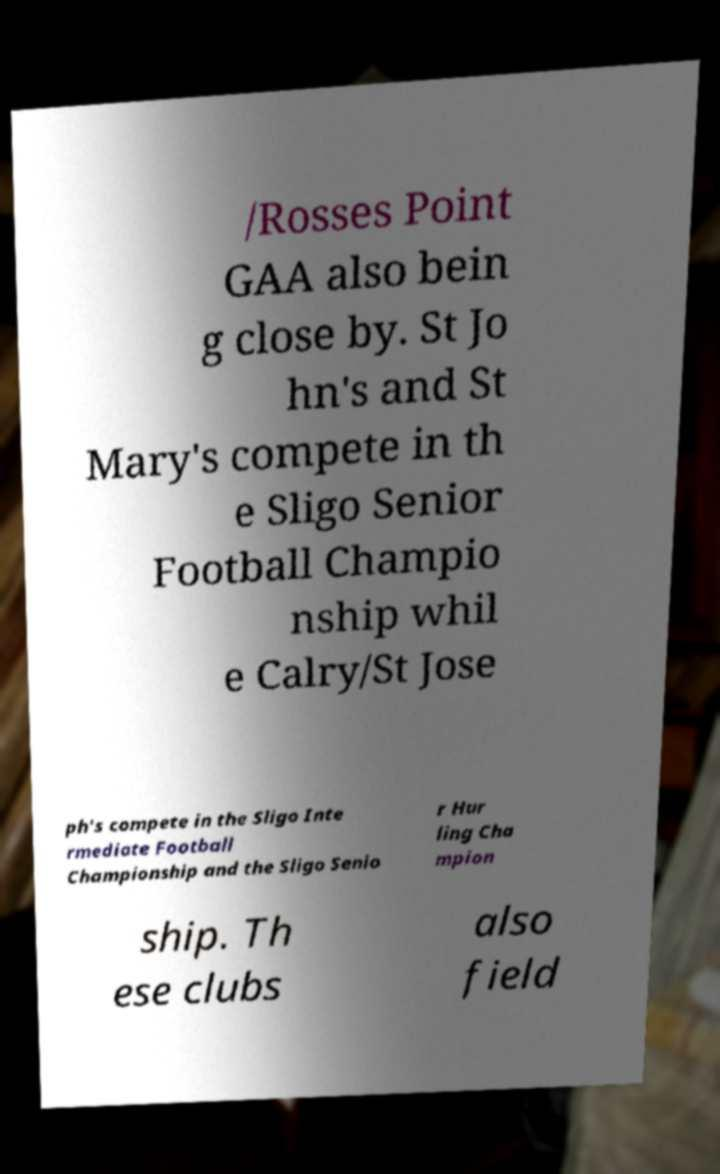Please read and relay the text visible in this image. What does it say? /Rosses Point GAA also bein g close by. St Jo hn's and St Mary's compete in th e Sligo Senior Football Champio nship whil e Calry/St Jose ph's compete in the Sligo Inte rmediate Football Championship and the Sligo Senio r Hur ling Cha mpion ship. Th ese clubs also field 